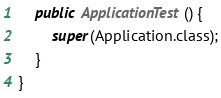<code> <loc_0><loc_0><loc_500><loc_500><_Java_>    public ApplicationTest() {
        super(Application.class);
    }
}</code> 